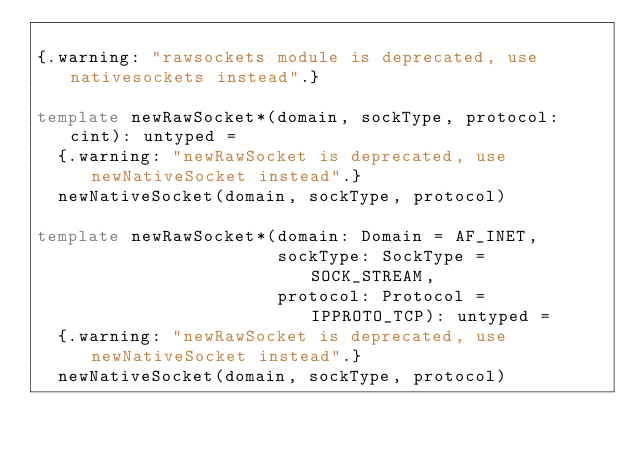<code> <loc_0><loc_0><loc_500><loc_500><_Nim_>
{.warning: "rawsockets module is deprecated, use nativesockets instead".}

template newRawSocket*(domain, sockType, protocol: cint): untyped =
  {.warning: "newRawSocket is deprecated, use newNativeSocket instead".}
  newNativeSocket(domain, sockType, protocol)

template newRawSocket*(domain: Domain = AF_INET,
                       sockType: SockType = SOCK_STREAM,
                       protocol: Protocol = IPPROTO_TCP): untyped =
  {.warning: "newRawSocket is deprecated, use newNativeSocket instead".}
  newNativeSocket(domain, sockType, protocol)
</code> 